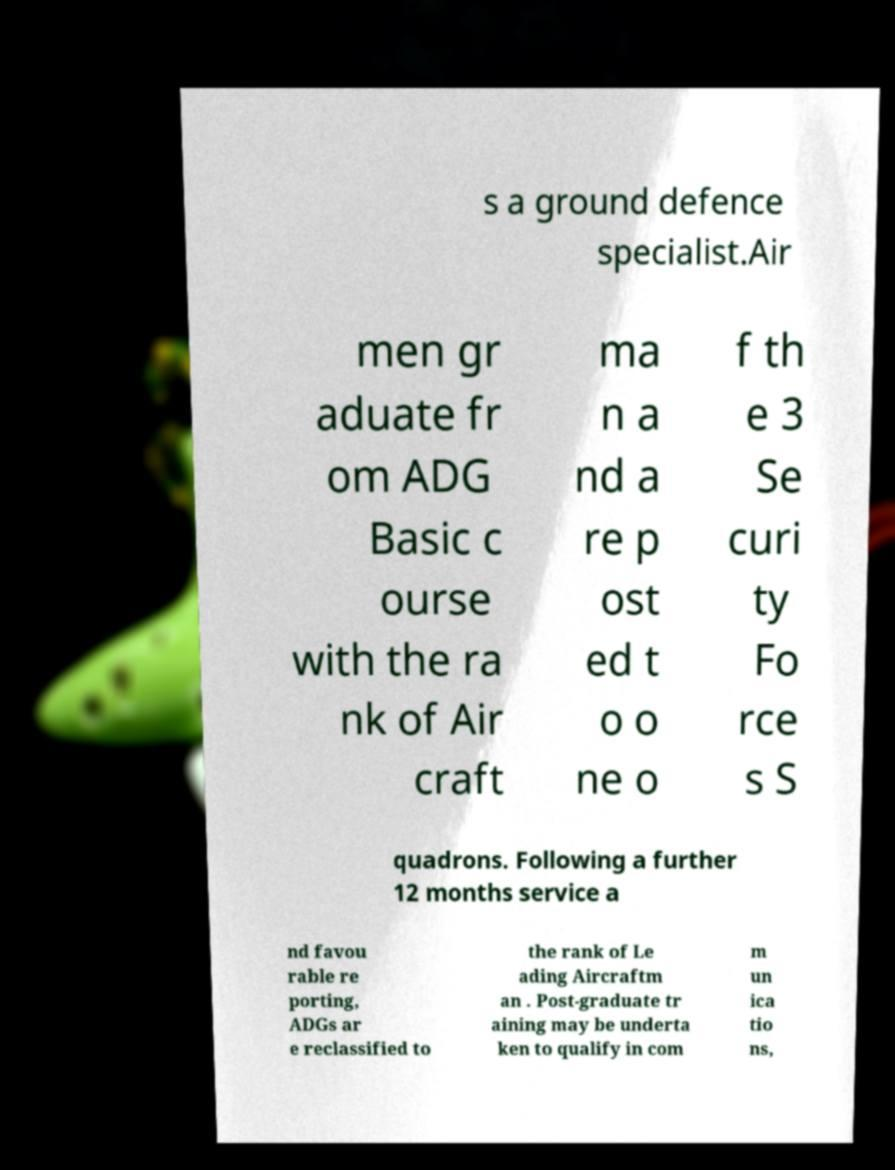Can you accurately transcribe the text from the provided image for me? s a ground defence specialist.Air men gr aduate fr om ADG Basic c ourse with the ra nk of Air craft ma n a nd a re p ost ed t o o ne o f th e 3 Se curi ty Fo rce s S quadrons. Following a further 12 months service a nd favou rable re porting, ADGs ar e reclassified to the rank of Le ading Aircraftm an . Post-graduate tr aining may be underta ken to qualify in com m un ica tio ns, 